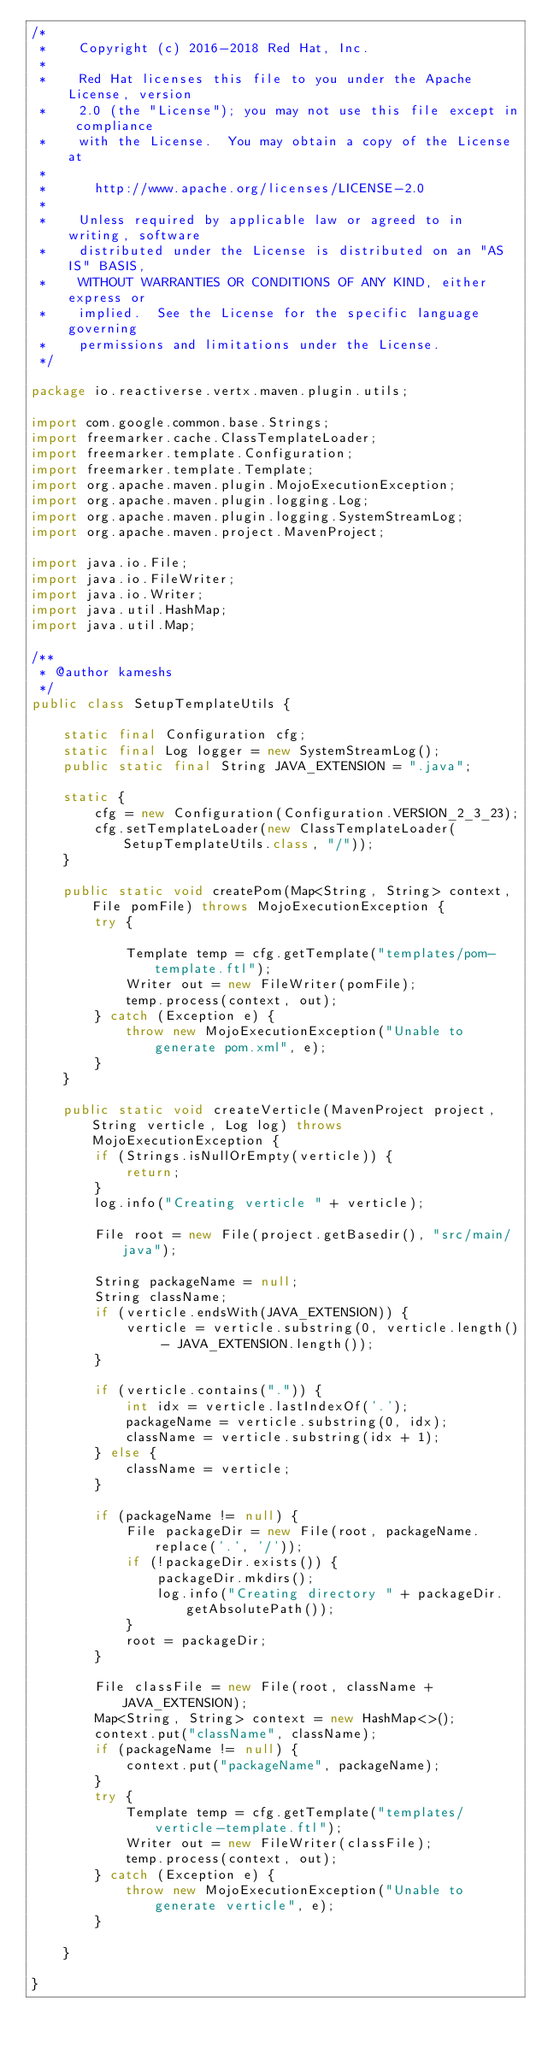Convert code to text. <code><loc_0><loc_0><loc_500><loc_500><_Java_>/*
 *    Copyright (c) 2016-2018 Red Hat, Inc.
 *
 *    Red Hat licenses this file to you under the Apache License, version
 *    2.0 (the "License"); you may not use this file except in compliance
 *    with the License.  You may obtain a copy of the License at
 *
 *      http://www.apache.org/licenses/LICENSE-2.0
 *
 *    Unless required by applicable law or agreed to in writing, software
 *    distributed under the License is distributed on an "AS IS" BASIS,
 *    WITHOUT WARRANTIES OR CONDITIONS OF ANY KIND, either express or
 *    implied.  See the License for the specific language governing
 *    permissions and limitations under the License.
 */

package io.reactiverse.vertx.maven.plugin.utils;

import com.google.common.base.Strings;
import freemarker.cache.ClassTemplateLoader;
import freemarker.template.Configuration;
import freemarker.template.Template;
import org.apache.maven.plugin.MojoExecutionException;
import org.apache.maven.plugin.logging.Log;
import org.apache.maven.plugin.logging.SystemStreamLog;
import org.apache.maven.project.MavenProject;

import java.io.File;
import java.io.FileWriter;
import java.io.Writer;
import java.util.HashMap;
import java.util.Map;

/**
 * @author kameshs
 */
public class SetupTemplateUtils {

    static final Configuration cfg;
    static final Log logger = new SystemStreamLog();
    public static final String JAVA_EXTENSION = ".java";

    static {
        cfg = new Configuration(Configuration.VERSION_2_3_23);
        cfg.setTemplateLoader(new ClassTemplateLoader(SetupTemplateUtils.class, "/"));
    }

    public static void createPom(Map<String, String> context, File pomFile) throws MojoExecutionException {
        try {

            Template temp = cfg.getTemplate("templates/pom-template.ftl");
            Writer out = new FileWriter(pomFile);
            temp.process(context, out);
        } catch (Exception e) {
            throw new MojoExecutionException("Unable to generate pom.xml", e);
        }
    }

    public static void createVerticle(MavenProject project, String verticle, Log log) throws MojoExecutionException {
        if (Strings.isNullOrEmpty(verticle)) {
            return;
        }
        log.info("Creating verticle " + verticle);

        File root = new File(project.getBasedir(), "src/main/java");

        String packageName = null;
        String className;
        if (verticle.endsWith(JAVA_EXTENSION)) {
            verticle = verticle.substring(0, verticle.length() - JAVA_EXTENSION.length());
        }

        if (verticle.contains(".")) {
            int idx = verticle.lastIndexOf('.');
            packageName = verticle.substring(0, idx);
            className = verticle.substring(idx + 1);
        } else {
            className = verticle;
        }

        if (packageName != null) {
            File packageDir = new File(root, packageName.replace('.', '/'));
            if (!packageDir.exists()) {
                packageDir.mkdirs();
                log.info("Creating directory " + packageDir.getAbsolutePath());
            }
            root = packageDir;
        }

        File classFile = new File(root, className + JAVA_EXTENSION);
        Map<String, String> context = new HashMap<>();
        context.put("className", className);
        if (packageName != null) {
            context.put("packageName", packageName);
        }
        try {
            Template temp = cfg.getTemplate("templates/verticle-template.ftl");
            Writer out = new FileWriter(classFile);
            temp.process(context, out);
        } catch (Exception e) {
            throw new MojoExecutionException("Unable to generate verticle", e);
        }

    }

}
</code> 